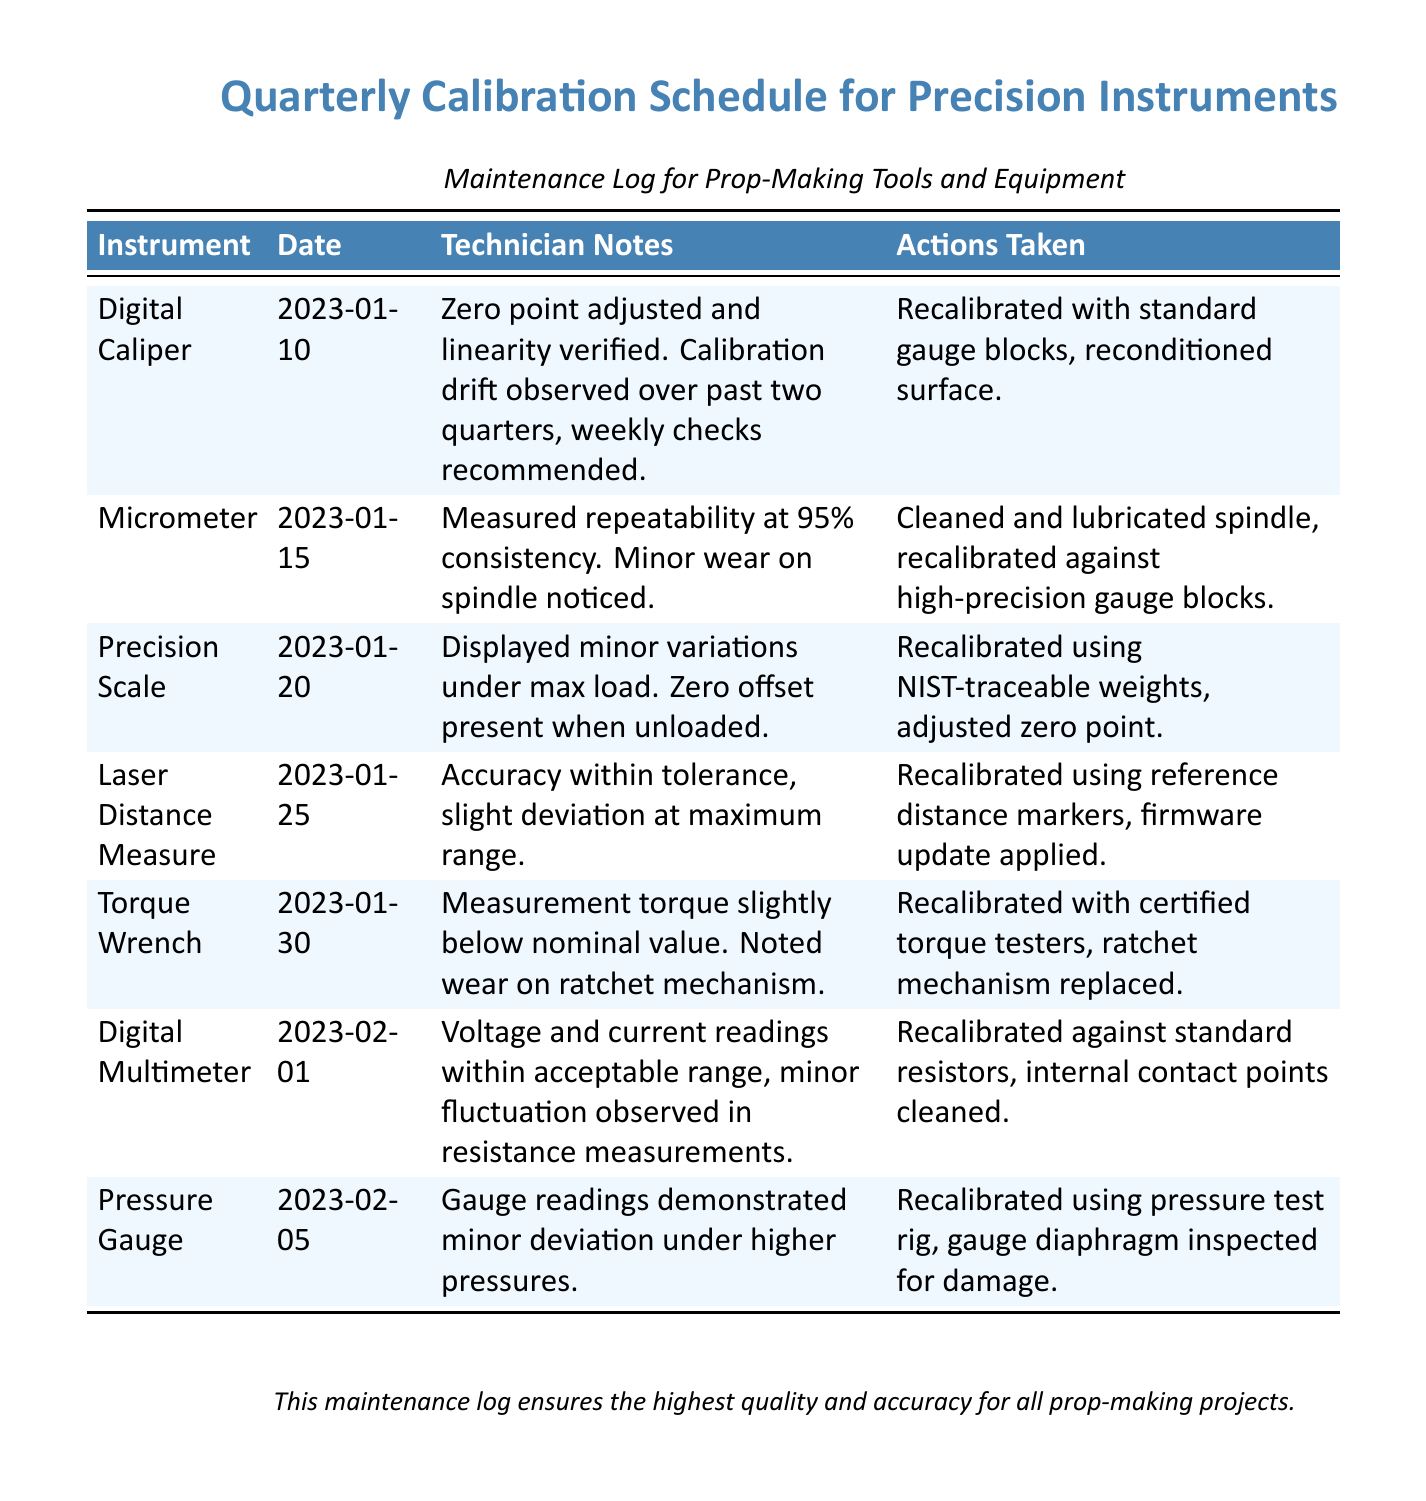What was the calibration date for the Digital Caliper? The calibration date for the Digital Caliper can be found in the document under the corresponding row.
Answer: 2023-01-10 What action was taken for the Pressure Gauge? The actions taken for the Pressure Gauge are listed in the document under its respective notes and actions section.
Answer: Recalibrated using pressure test rig, gauge diaphragm inspected for damage What is noted about the Micrometer's spindle? The technician notes mention specific observations regarding the Micrometer’s condition, captured in the document.
Answer: Minor wear on spindle noticed How many instruments were calibrated on January 25, 2023? By counting the entries that fall on this date in the table, one can determine the number of instruments.
Answer: One What calibration checks are recommended for the Digital Caliper? The recommendations for follow-up checks are listed in the technician notes for the Digital Caliper within the document.
Answer: Weekly checks recommended What was the issue noted with the Torque Wrench? The Technician Notes for the Torque Wrench detail specific problems during calibration found in the document.
Answer: Measurement torque slightly below nominal value What type of weights were used to recalibrate the Precision Scale? The types of calibration weights utilized are specified in the document, under the actions taken for Precision Scale.
Answer: NIST-traceable weights Which instrument had a firmware update applied during calibration? The action taken on the Laser Distance Measure includes specific actions from the document.
Answer: Laser Distance Measure 